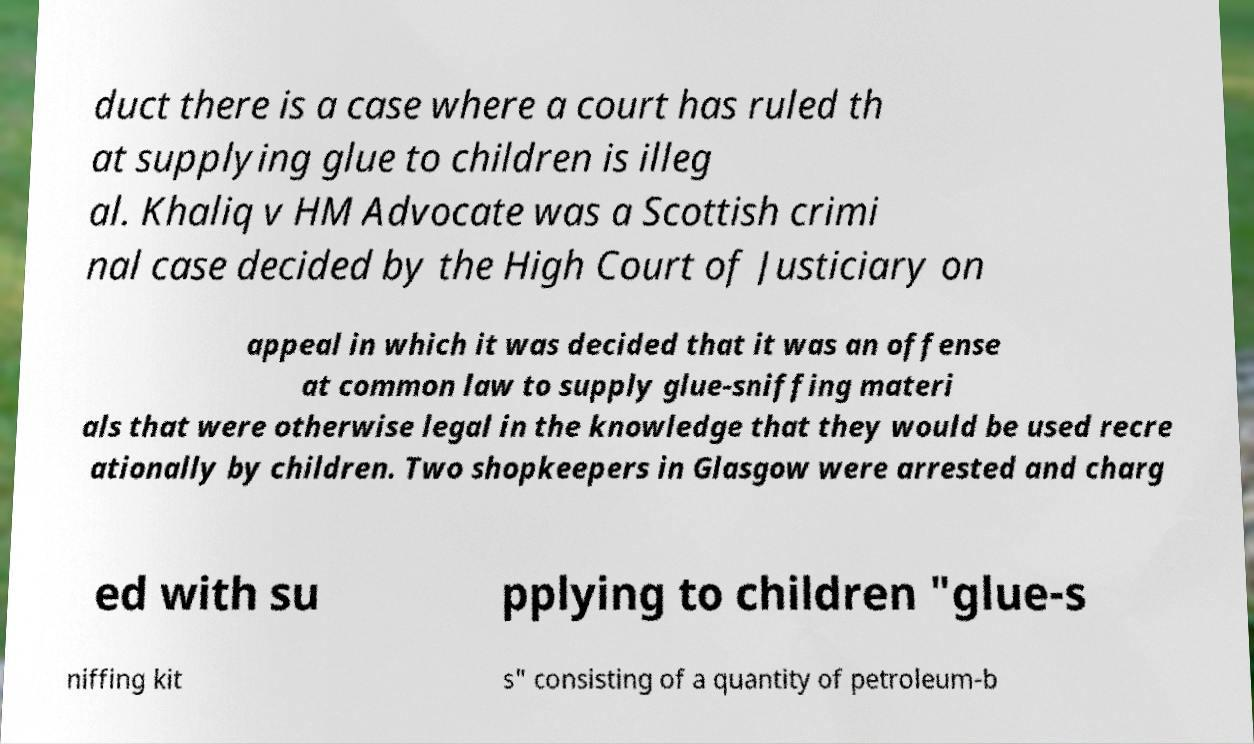Please identify and transcribe the text found in this image. duct there is a case where a court has ruled th at supplying glue to children is illeg al. Khaliq v HM Advocate was a Scottish crimi nal case decided by the High Court of Justiciary on appeal in which it was decided that it was an offense at common law to supply glue-sniffing materi als that were otherwise legal in the knowledge that they would be used recre ationally by children. Two shopkeepers in Glasgow were arrested and charg ed with su pplying to children "glue-s niffing kit s" consisting of a quantity of petroleum-b 